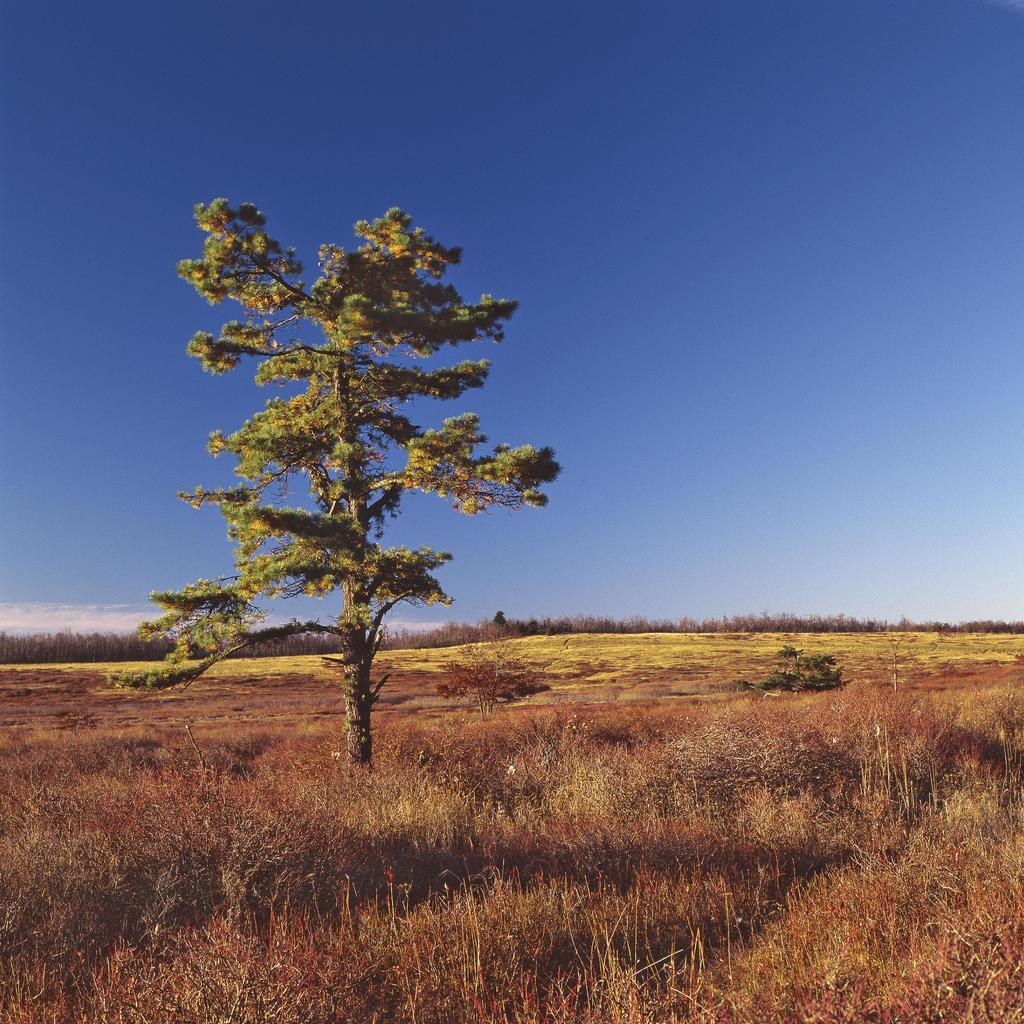What type of plant can be seen in the image? There is a tree in the image. What type of vegetation is present at the bottom of the image? There is grass at the bottom of the image. What part of the natural environment is visible in the background of the image? The sky is visible in the background of the image. What type of debt is being discussed by the flock of birds in the image? There are no birds present in the image, and therefore no discussion of debt can be observed. 